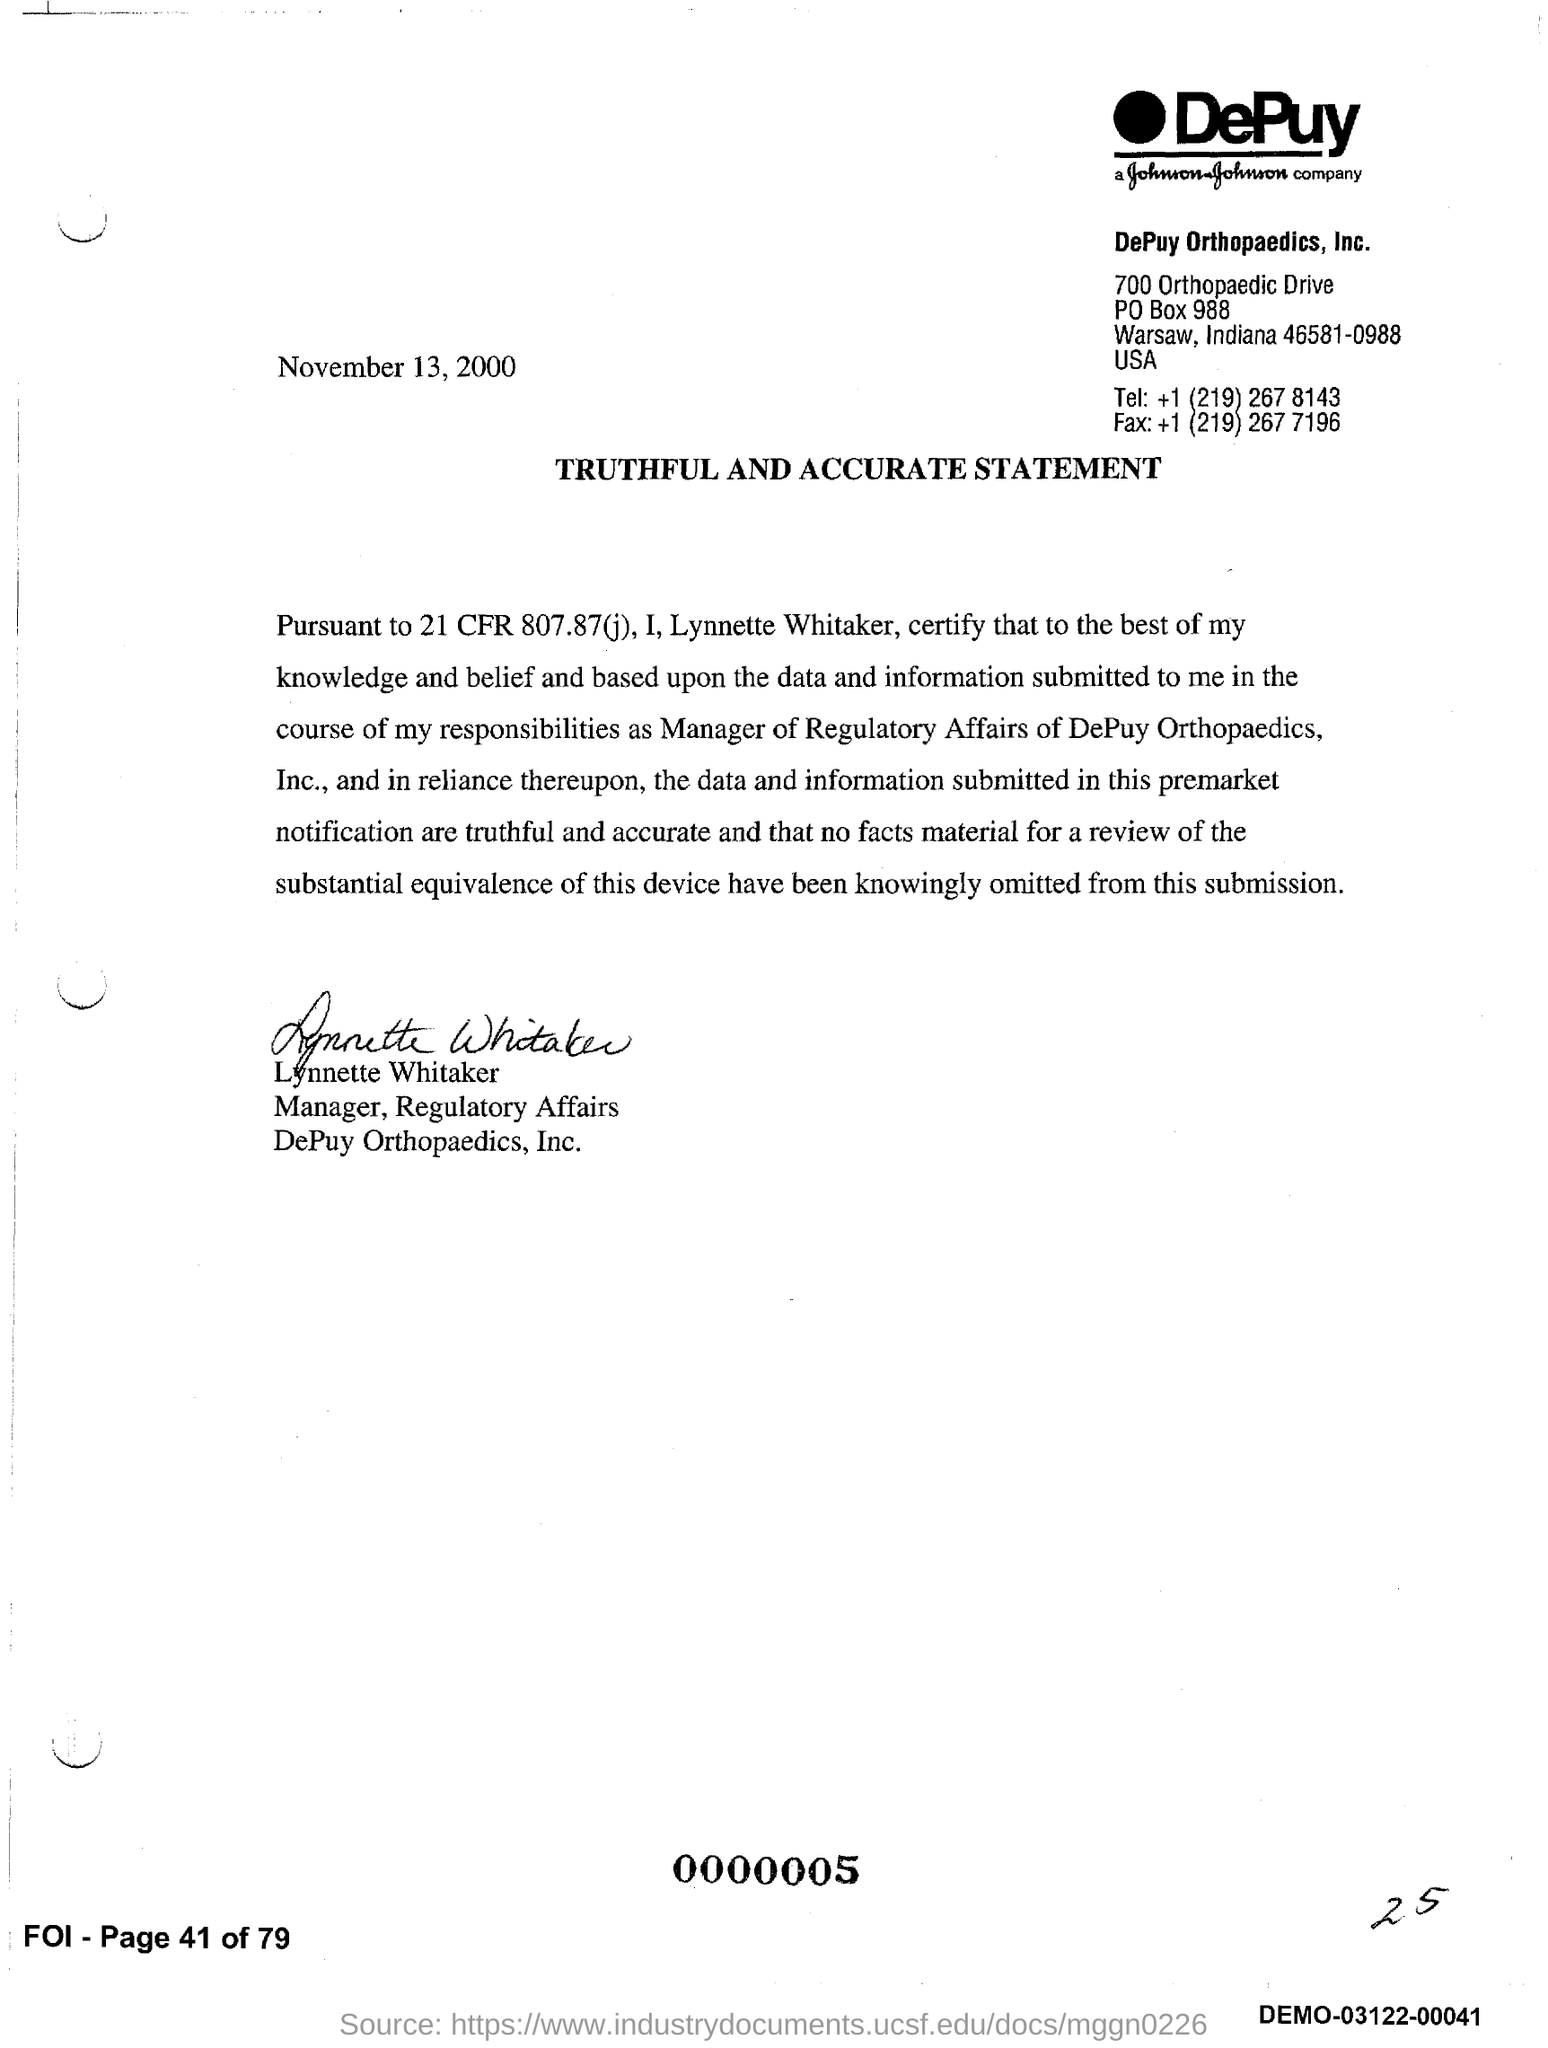What is the date of the statement document?
Keep it short and to the point. November 13, 2000. What is the title of the document?
Your answer should be very brief. Truthful and accurate Statement. What is the name of the person who signed the document
Your response must be concise. Lynnette Whitaker. 